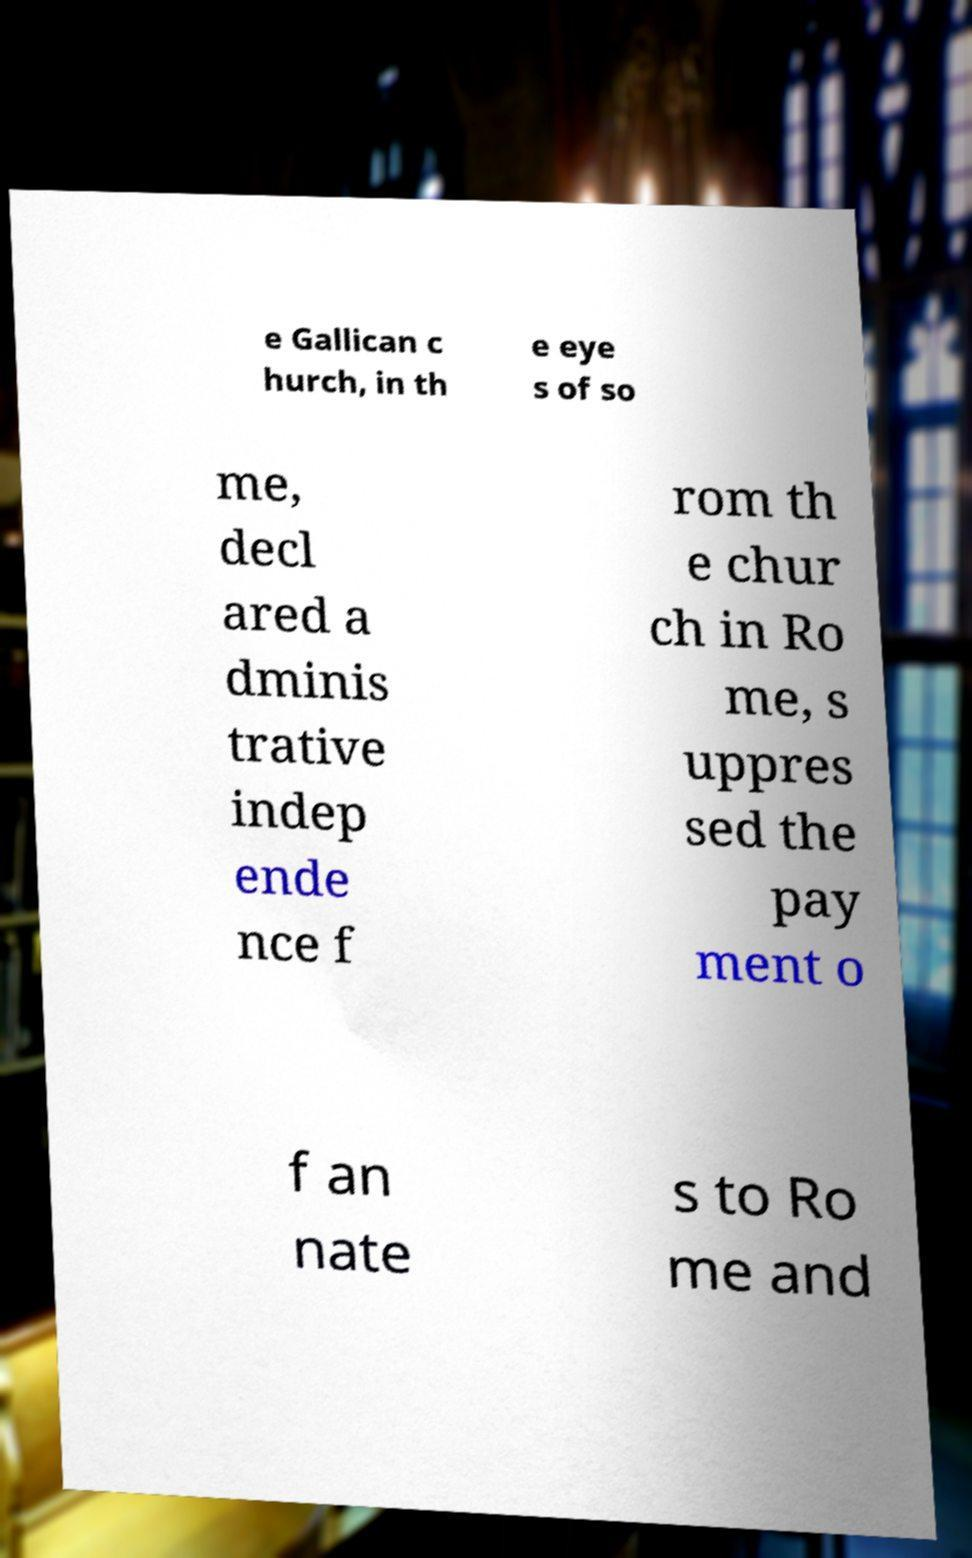Could you assist in decoding the text presented in this image and type it out clearly? e Gallican c hurch, in th e eye s of so me, decl ared a dminis trative indep ende nce f rom th e chur ch in Ro me, s uppres sed the pay ment o f an nate s to Ro me and 